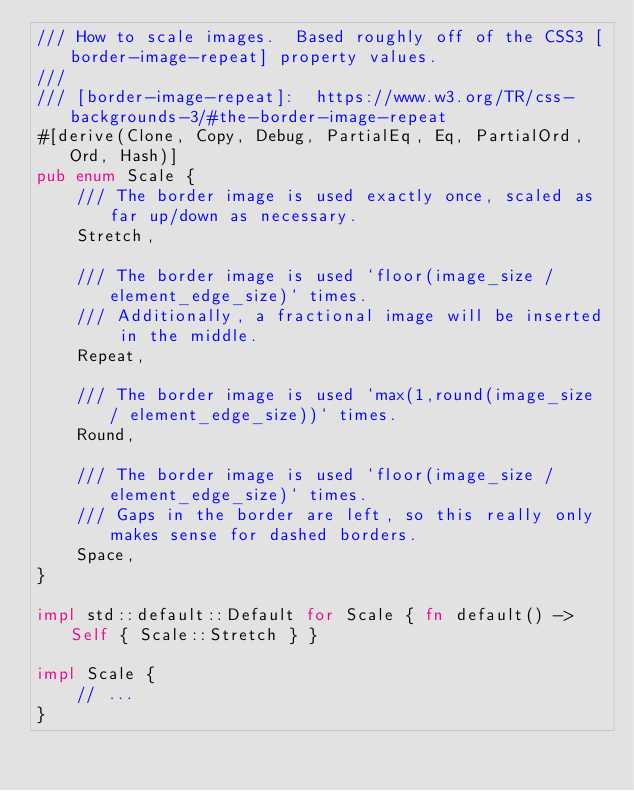Convert code to text. <code><loc_0><loc_0><loc_500><loc_500><_Rust_>/// How to scale images.  Based roughly off of the CSS3 [border-image-repeat] property values.
/// 
/// [border-image-repeat]:  https://www.w3.org/TR/css-backgrounds-3/#the-border-image-repeat
#[derive(Clone, Copy, Debug, PartialEq, Eq, PartialOrd, Ord, Hash)]
pub enum Scale {
    /// The border image is used exactly once, scaled as far up/down as necessary.
    Stretch,

    /// The border image is used `floor(image_size / element_edge_size)` times.
    /// Additionally, a fractional image will be inserted in the middle.
    Repeat,

    /// The border image is used `max(1,round(image_size / element_edge_size))` times.
    Round,

    /// The border image is used `floor(image_size / element_edge_size)` times.
    /// Gaps in the border are left, so this really only makes sense for dashed borders.
    Space,
}

impl std::default::Default for Scale { fn default() -> Self { Scale::Stretch } }

impl Scale {
    // ...
}
</code> 